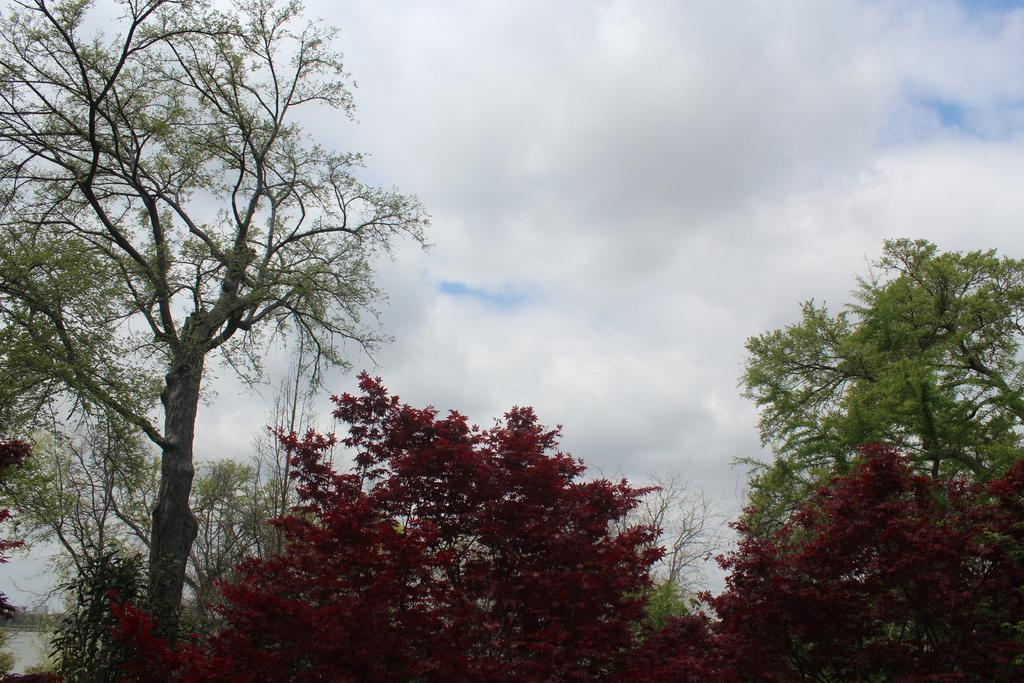What type of vegetation is in the foreground of the image? There are trees in the foreground of the image. What structure can be seen on the left side of the image? There is a building on the left side of the image. What is visible at the top of the image? The sky is visible at the top of the image. What can be observed in the sky? There are clouds in the sky. How many arms are visible on the trees in the image? Trees do not have arms; they have branches. The image does not show any visible branches that could be mistaken for arms. --- 